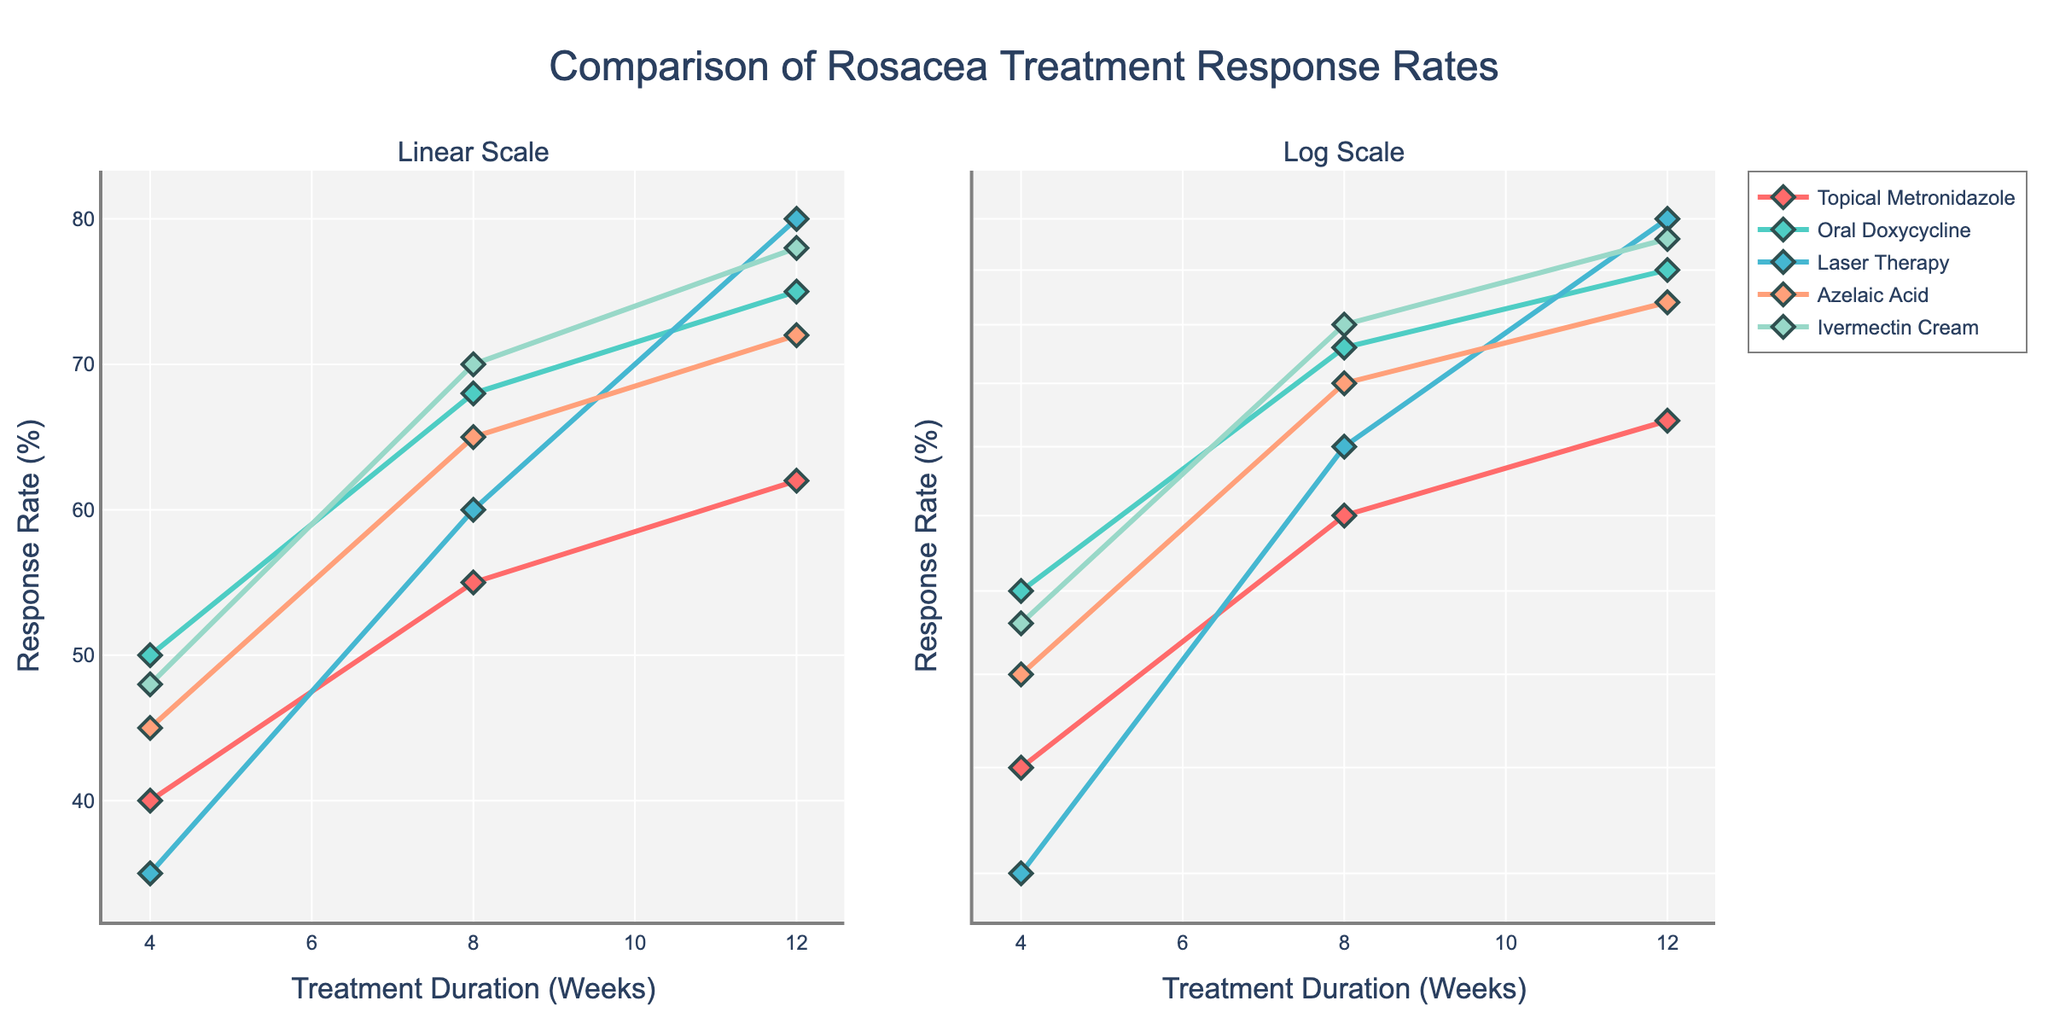What is the title of the plot? The title of the plot is displayed at the top center of the figure. From the data and code, it is 'Comparison of Rosacea Treatment Response Rates'.
Answer: Comparison of Rosacea Treatment Response Rates What are the treatments compared in the figure? The treatments are listed in the legend and indicated by different colors. The treatments are: Topical Metronidazole, Oral Doxycycline, Laser Therapy, Azelaic Acid, and Ivermectin Cream.
Answer: Topical Metronidazole, Oral Doxycycline, Laser Therapy, Azelaic Acid, Ivermectin Cream What is the maximum response rate and which treatment achieves it? From the data points plotted, the highest response rate can be identified. Laser Therapy has the maximum response rate of 80% at 12 weeks.
Answer: 80%, Laser Therapy What is the general trend of the response rates over the duration of treatments? All treatments show plotted lines with increasing response rates as the duration increases from 4 to 12 weeks. This indicates a positive trend for all treatments over time.
Answer: Increasing Which treatment shows the largest increase in response rate from week 4 to week 8? Calculate the difference in response rate from week 4 to week 8 for all treatments. Laser Therapy increases from 35% to 60%, giving a 25% increase, which is the largest.
Answer: Laser Therapy Comparing the linear and log scale subplots, does any treatment show a different pattern in response rates? Observe the shapes of the curves in both subplots. Even in log scale, the general pattern of increasing response rates over time is consistent, no treatment shows a distinctly different pattern compared to the linear scale.
Answer: No Which treatment has the least response rate at 4 weeks and what is it? The lowest value at week 4 can be found by examining the starting points of the lines in the plots. Laser Therapy has the least response rate of 35% at 4 weeks.
Answer: Laser Therapy, 35% How does the response rate of Azelaic Acid at 12 weeks compare to Oral Doxycycline at 12 weeks? Compare the points for Azelaic Acid and Oral Doxycycline at 12 weeks from the lines in the plots. Azelaic Acid has a response rate of 72%, while Oral Doxycycline has 75%, making Oral Doxycycline slightly higher.
Answer: Azelaic Acid: 72%, Oral Doxycycline: 75% What is the median response rate of Ivermectin Cream over the 12 weeks? List out the response rates for Ivermectin Cream: 48% at 4 weeks, 70% at 8 weeks, and 78% at 12 weeks. To find the median, sort the response rates and pick the middle value, which is 70%.
Answer: 70% Which treatment shows the smallest increase in response rate from week 8 to week 12? Calculate the difference in response rates from week 8 to week 12 for all treatments. Topical Metronidazole increases from 55% to 62%, giving a 7% increase, which is the smallest.
Answer: Topical Metronidazole 